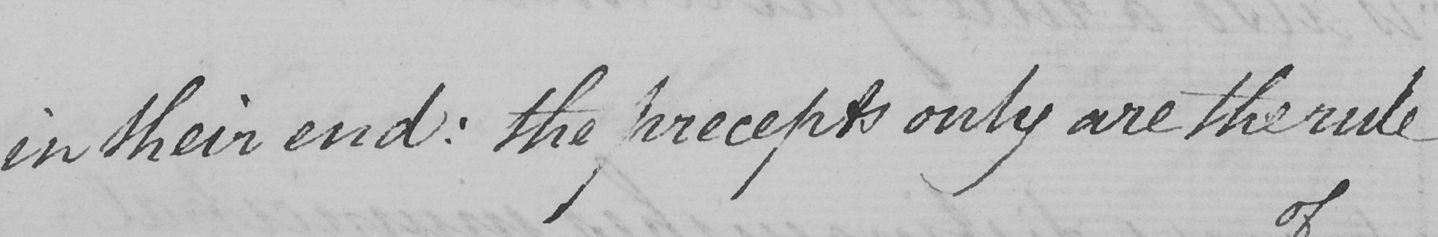Please provide the text content of this handwritten line. in their end :  the precepts only are the rule 